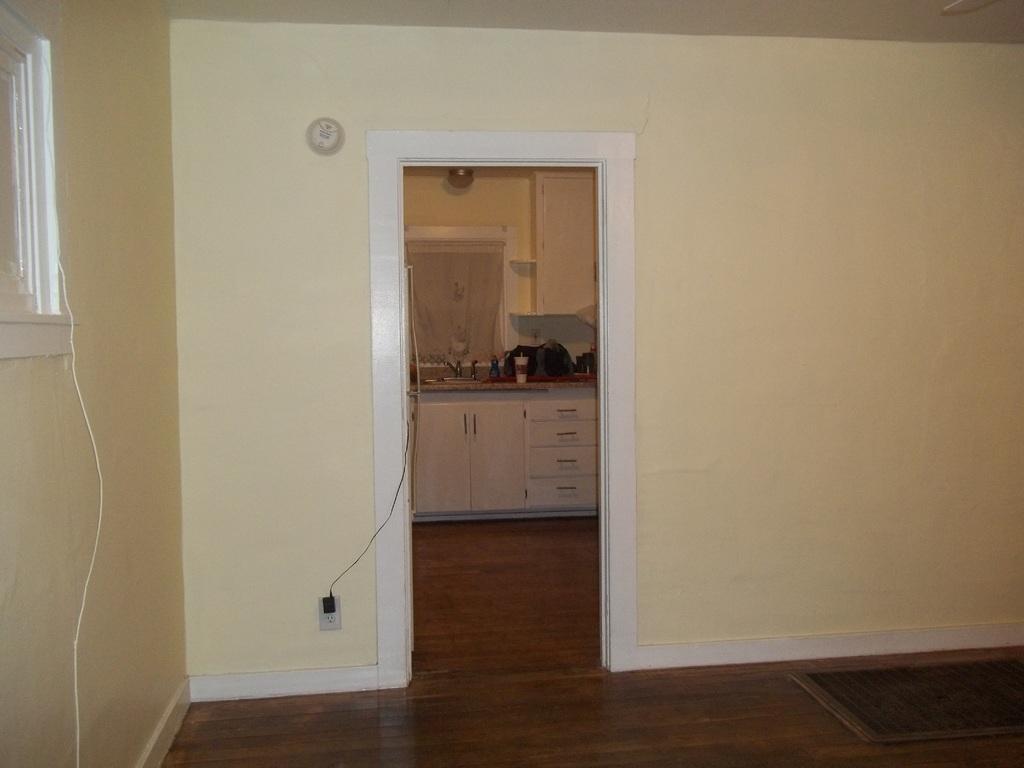Please provide a concise description of this image. This image is clicked in a room. In the front, there is a kitchen. At the bottom, there is floor. In the front, there are walls along with window. 